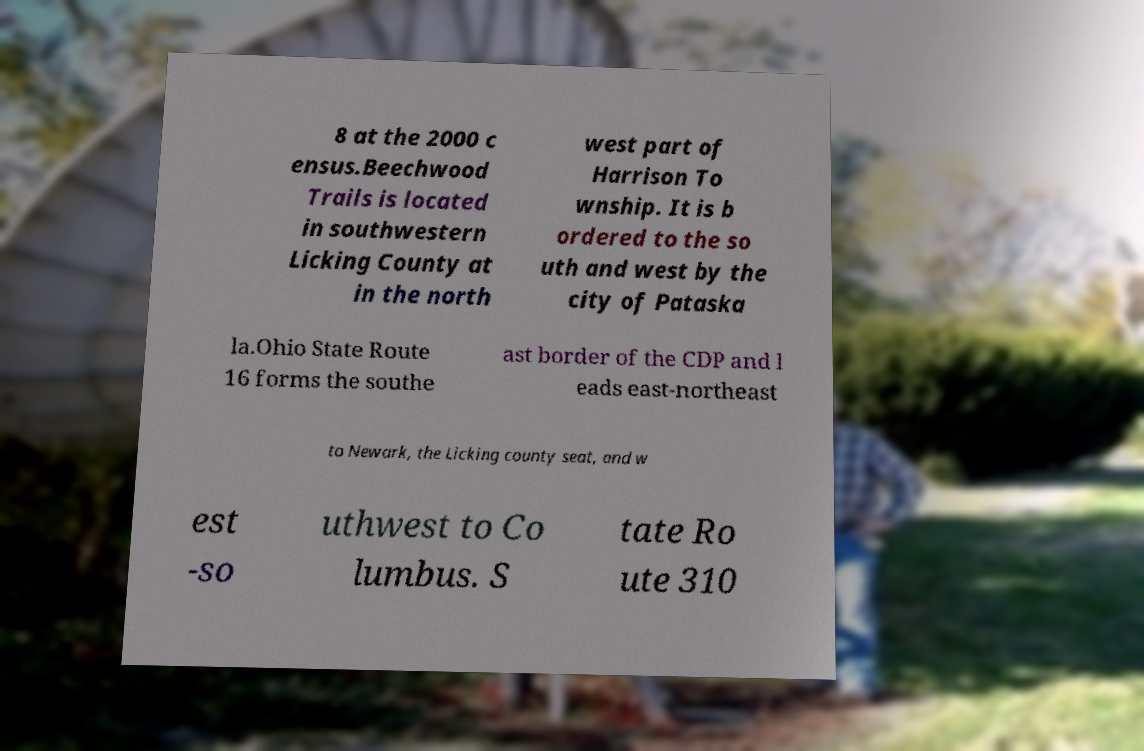Could you assist in decoding the text presented in this image and type it out clearly? 8 at the 2000 c ensus.Beechwood Trails is located in southwestern Licking County at in the north west part of Harrison To wnship. It is b ordered to the so uth and west by the city of Pataska la.Ohio State Route 16 forms the southe ast border of the CDP and l eads east-northeast to Newark, the Licking county seat, and w est -so uthwest to Co lumbus. S tate Ro ute 310 